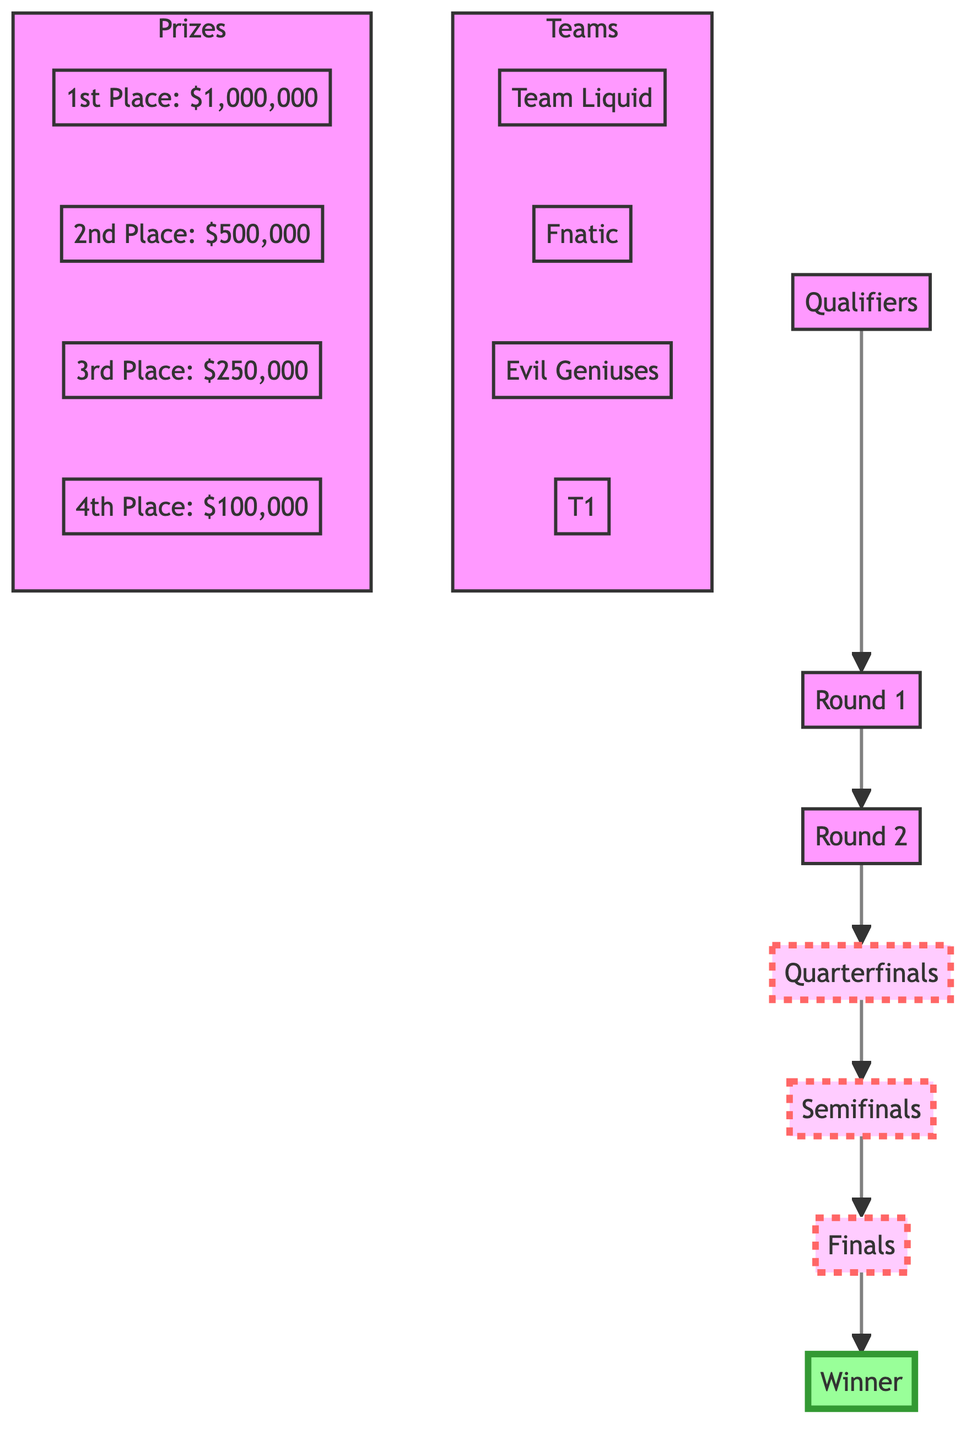What is the first stage of the tournament? The diagram starts with a node labeled "Qualifiers," indicating that this is the initial stage of the competitive tournament.
Answer: Qualifiers How many rounds are there in the tournament structure? By following the arrows in the diagram, we see the sequence from "Qualifiers" to "Finals," which includes five distinct rounds: Qualifiers, Round 1, Round 2, Quarterfinals, Semifinals, and Finals.
Answer: 5 Which team is in the tournament? The subgraph labeled "Teams" lists four specific teams, including "Team Liquid," which is one specific example of a participating team.
Answer: Team Liquid What is the prize for the 1st place? In the subgraph labeled "Prizes," the prize amount for the 1st place is clearly indicated as "$1,000,000," showing the monetary reward for the top team in the tournament.
Answer: $1,000,000 What progression follows after Quarterfinals? According to the flow in the diagram, the progression after "Quarterfinals" leads to "Semifinals" as the next stage for the winning teams.
Answer: Semifinals How many teams participate in the tournament shown in the diagram? There are four teams listed within the "Teams" subgraph, which indicates the total number of teams in this tournament structure.
Answer: 4 What is the total prize amount for the 2nd and 3rd places combined? The prize for 2nd place is $500,000 and for 3rd place is $250,000. Adding these amounts together gives a total of $750,000 as the combined prize for both places.
Answer: $750,000 Which round is labeled as the final stage of the tournament? The label "Finals" is present in the diagram, indicating that it is the last round where the ultimate match of the tournament occurs to determine the winner.
Answer: Finals Which subgraph represents the prizes in the tournament? The diagram contains a subgraph specifically labeled "Prizes," which explicitly outlines the monetary rewards for the top four placements.
Answer: Prizes 